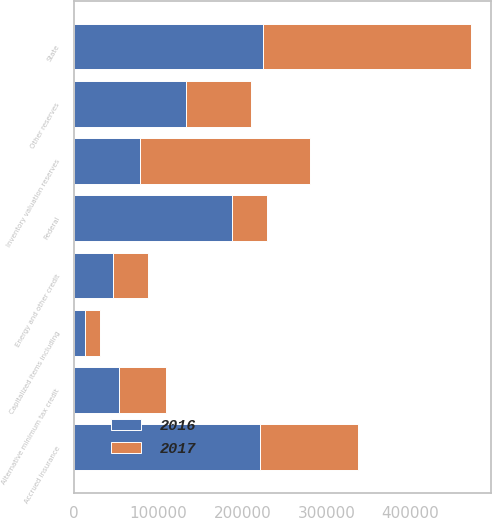<chart> <loc_0><loc_0><loc_500><loc_500><stacked_bar_chart><ecel><fcel>Accrued insurance<fcel>Inventory valuation reserves<fcel>Other reserves<fcel>Federal<fcel>State<fcel>Alternative minimum tax credit<fcel>Energy and other credit<fcel>Capitalized items including<nl><fcel>2017<fcel>117133<fcel>202791<fcel>78271<fcel>41282<fcel>248224<fcel>54965<fcel>41763<fcel>17895<nl><fcel>2016<fcel>220823<fcel>78271<fcel>132597<fcel>187817<fcel>224316<fcel>53917<fcel>45673<fcel>13054<nl></chart> 